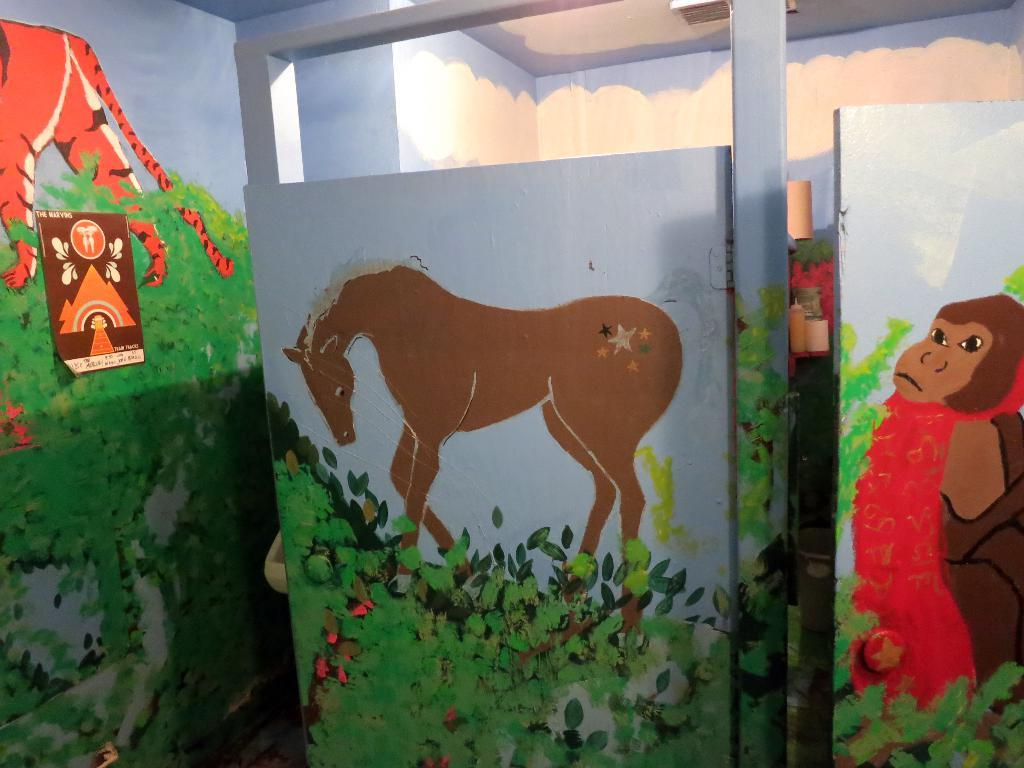What is the main feature of the wall in the image? The wall is painted with greenery in the image. What animals are depicted on the wall? There is a horse and a monkey depicted on the wall. What is the purpose of the door in the image? The door provides access to another room, which is visible behind it. How does the horse show respect to the monkey in the image? There is no interaction between the horse and the monkey in the image, so it is not possible to determine how the horse might show respect. 